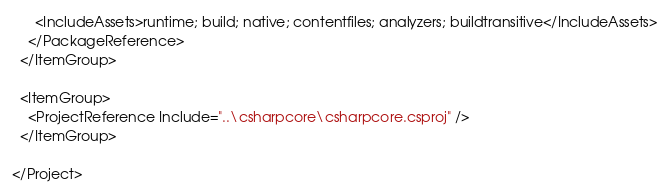<code> <loc_0><loc_0><loc_500><loc_500><_XML_>      <IncludeAssets>runtime; build; native; contentfiles; analyzers; buildtransitive</IncludeAssets>
    </PackageReference>
  </ItemGroup>

  <ItemGroup>
    <ProjectReference Include="..\csharpcore\csharpcore.csproj" />
  </ItemGroup>

</Project>
</code> 